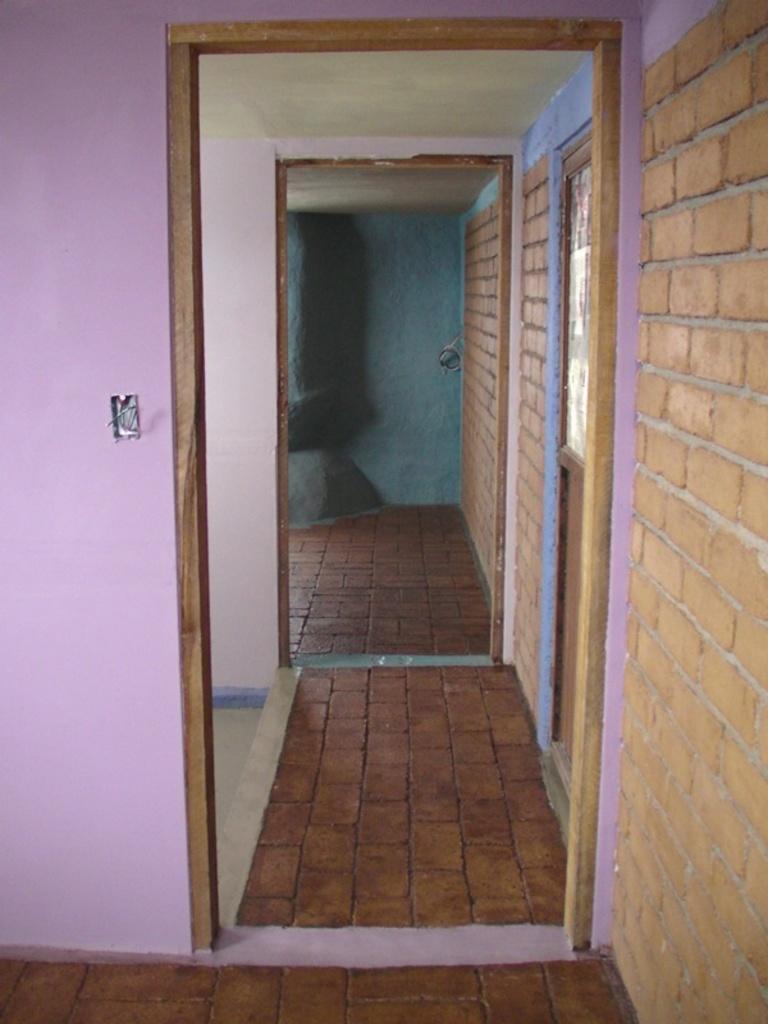How would you summarize this image in a sentence or two? In this image I can see the inner part of the house. I can see the walls are in pink and blue color. To the right I can see the brown color brick wall. 